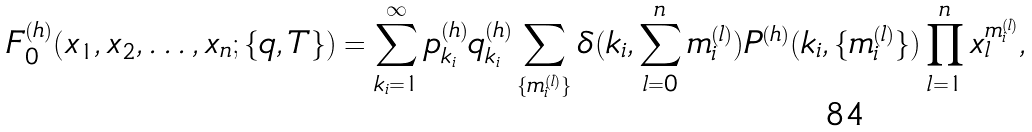<formula> <loc_0><loc_0><loc_500><loc_500>F _ { 0 } ^ { ( h ) } ( x _ { 1 } , x _ { 2 } , \dots , x _ { n } ; \{ q , T \} ) = \sum _ { k _ { i } = 1 } ^ { \infty } p _ { k _ { i } } ^ { ( h ) } q _ { k _ { i } } ^ { ( h ) } \sum _ { \{ m ^ { ( l ) } _ { i } \} } \delta ( k _ { i } , \sum _ { l = 0 } ^ { n } m ^ { ( l ) } _ { i } ) P ^ { ( h ) } ( k _ { i } , \{ m ^ { ( l ) } _ { i } \} ) \prod _ { l = 1 } ^ { n } x _ { l } ^ { m ^ { ( l ) } _ { i } } ,</formula> 